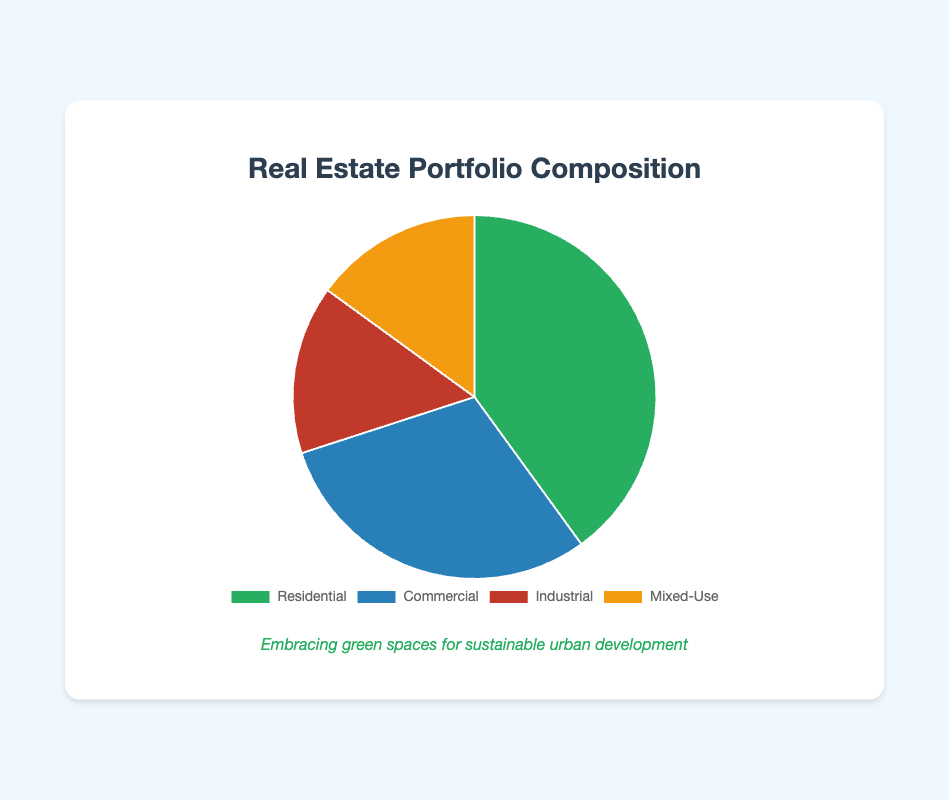what proportion of the real estate portfolio is residential? Refer to the pie chart. The slice labeled "Residential" represents 40% of the portfolio
Answer: 40% which property type has the smallest proportion in the portfolio? Refer to the pie chart. Both "Industrial" and "Mixed-Use" categories have the smallest proportion, each representing 15%
Answer: Industrial and Mixed-Use how much larger is the residential proportion compared to the industrial proportion? The residential proportion is 40%. The industrial proportion is 15%. The difference is 40% - 15% = 25%
Answer: 25% what is the combined proportion of industrial and mixed-use properties? The industrial proportion is 15% and the mixed-use proportion is 15%. Combined, they represent 15% + 15% = 30%
Answer: 30% is the commercial portion greater than the combined industrial and mixed-use portions? The commercial proportion is 30%. The combined industrial and mixed-use proportion is 15% + 15% = 30%. Therefore, they are equal
Answer: No which slice in the pie chart is colored green? Refer to the pie chart. The slice colored green represents the "Residential" category
Answer: Residential what percentage of the portfolio is non-residential? The residential proportion is 40%, so the non-residential proportion is 100% - 40% = 60%
Answer: 60% is the commercial portion smaller than the residential portion but larger than the industrial portion? The commercial portion is 30%, the residential portion is 40%, and the industrial portion is 15%. 30% is indeed smaller than 40% and larger than 15%
Answer: Yes what is the ratio of residential to the total proportion of commercial and mixed-use together? The residential proportion is 40%. The combined commercial and mixed-use proportion is 30% + 15% = 45%. The ratio is 40% / 45% ≈ 0.89
Answer: 0.89 if 10% of the residential properties are to be converted to mixed-use, what would be the new proportions of residential and mixed-use respectively? If 10% of the residential properties (40% of the total portfolio) are converted to mixed-use, 10% of 40% is 4%. The new residential proportion would be 40% - 4% = 36%, and the new mixed-use proportion would be 15% + 4% = 19%
Answer: Residential: 36%, Mixed-Use: 19% 